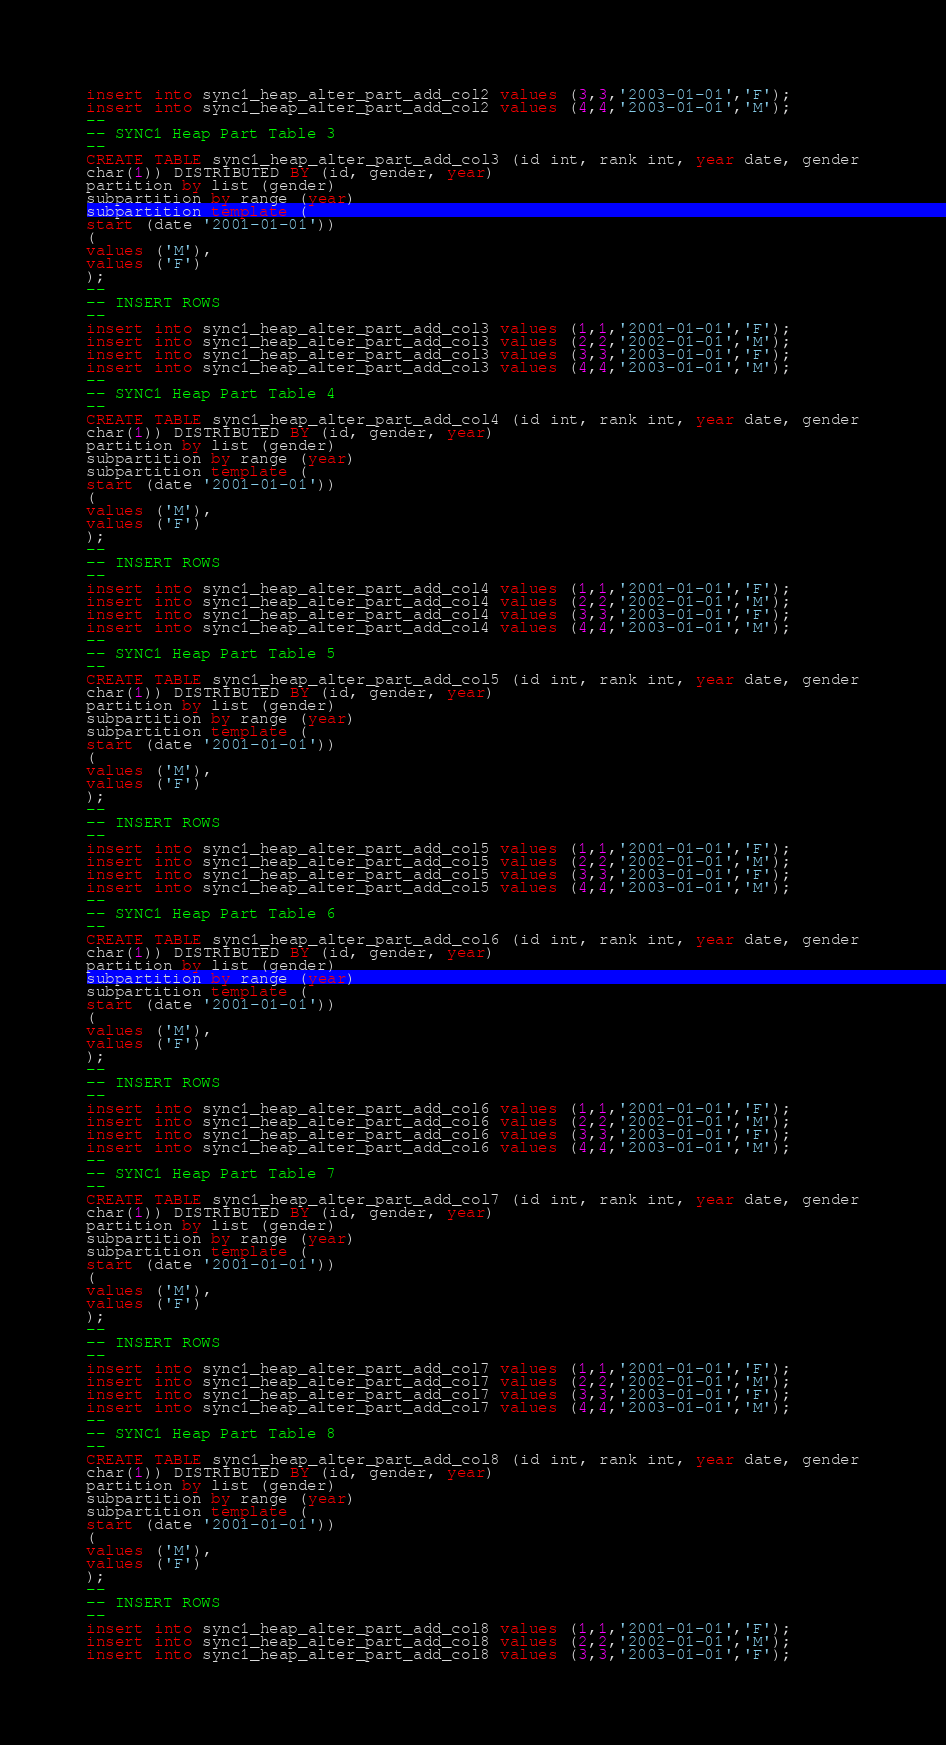Convert code to text. <code><loc_0><loc_0><loc_500><loc_500><_SQL_>insert into sync1_heap_alter_part_add_col2 values (3,3,'2003-01-01','F');
insert into sync1_heap_alter_part_add_col2 values (4,4,'2003-01-01','M');
--
-- SYNC1 Heap Part Table 3
--
CREATE TABLE sync1_heap_alter_part_add_col3 (id int, rank int, year date, gender
char(1)) DISTRIBUTED BY (id, gender, year)
partition by list (gender)
subpartition by range (year)
subpartition template (
start (date '2001-01-01'))
(
values ('M'),
values ('F')
);
--
-- INSERT ROWS
--
insert into sync1_heap_alter_part_add_col3 values (1,1,'2001-01-01','F');
insert into sync1_heap_alter_part_add_col3 values (2,2,'2002-01-01','M');
insert into sync1_heap_alter_part_add_col3 values (3,3,'2003-01-01','F');
insert into sync1_heap_alter_part_add_col3 values (4,4,'2003-01-01','M');
--
-- SYNC1 Heap Part Table 4
--
CREATE TABLE sync1_heap_alter_part_add_col4 (id int, rank int, year date, gender
char(1)) DISTRIBUTED BY (id, gender, year)
partition by list (gender)
subpartition by range (year)
subpartition template (
start (date '2001-01-01'))
(
values ('M'),
values ('F')
);
--
-- INSERT ROWS
--
insert into sync1_heap_alter_part_add_col4 values (1,1,'2001-01-01','F');
insert into sync1_heap_alter_part_add_col4 values (2,2,'2002-01-01','M');
insert into sync1_heap_alter_part_add_col4 values (3,3,'2003-01-01','F');
insert into sync1_heap_alter_part_add_col4 values (4,4,'2003-01-01','M');
--
-- SYNC1 Heap Part Table 5
--
CREATE TABLE sync1_heap_alter_part_add_col5 (id int, rank int, year date, gender
char(1)) DISTRIBUTED BY (id, gender, year)
partition by list (gender)
subpartition by range (year)
subpartition template (
start (date '2001-01-01'))
(
values ('M'),
values ('F')
);
--
-- INSERT ROWS
--
insert into sync1_heap_alter_part_add_col5 values (1,1,'2001-01-01','F');
insert into sync1_heap_alter_part_add_col5 values (2,2,'2002-01-01','M');
insert into sync1_heap_alter_part_add_col5 values (3,3,'2003-01-01','F');
insert into sync1_heap_alter_part_add_col5 values (4,4,'2003-01-01','M');
--
-- SYNC1 Heap Part Table 6
--
CREATE TABLE sync1_heap_alter_part_add_col6 (id int, rank int, year date, gender
char(1)) DISTRIBUTED BY (id, gender, year)
partition by list (gender)
subpartition by range (year)
subpartition template (
start (date '2001-01-01'))
(
values ('M'),
values ('F')
);
--
-- INSERT ROWS
--
insert into sync1_heap_alter_part_add_col6 values (1,1,'2001-01-01','F');
insert into sync1_heap_alter_part_add_col6 values (2,2,'2002-01-01','M');
insert into sync1_heap_alter_part_add_col6 values (3,3,'2003-01-01','F');
insert into sync1_heap_alter_part_add_col6 values (4,4,'2003-01-01','M');
--
-- SYNC1 Heap Part Table 7
--
CREATE TABLE sync1_heap_alter_part_add_col7 (id int, rank int, year date, gender
char(1)) DISTRIBUTED BY (id, gender, year)
partition by list (gender)
subpartition by range (year)
subpartition template (
start (date '2001-01-01'))
(
values ('M'),
values ('F')
);
--
-- INSERT ROWS
--
insert into sync1_heap_alter_part_add_col7 values (1,1,'2001-01-01','F');
insert into sync1_heap_alter_part_add_col7 values (2,2,'2002-01-01','M');
insert into sync1_heap_alter_part_add_col7 values (3,3,'2003-01-01','F');
insert into sync1_heap_alter_part_add_col7 values (4,4,'2003-01-01','M');
--
-- SYNC1 Heap Part Table 8
--
CREATE TABLE sync1_heap_alter_part_add_col8 (id int, rank int, year date, gender
char(1)) DISTRIBUTED BY (id, gender, year)
partition by list (gender)
subpartition by range (year)
subpartition template (
start (date '2001-01-01'))
(
values ('M'),
values ('F')
);
--
-- INSERT ROWS
--
insert into sync1_heap_alter_part_add_col8 values (1,1,'2001-01-01','F');
insert into sync1_heap_alter_part_add_col8 values (2,2,'2002-01-01','M');
insert into sync1_heap_alter_part_add_col8 values (3,3,'2003-01-01','F');</code> 